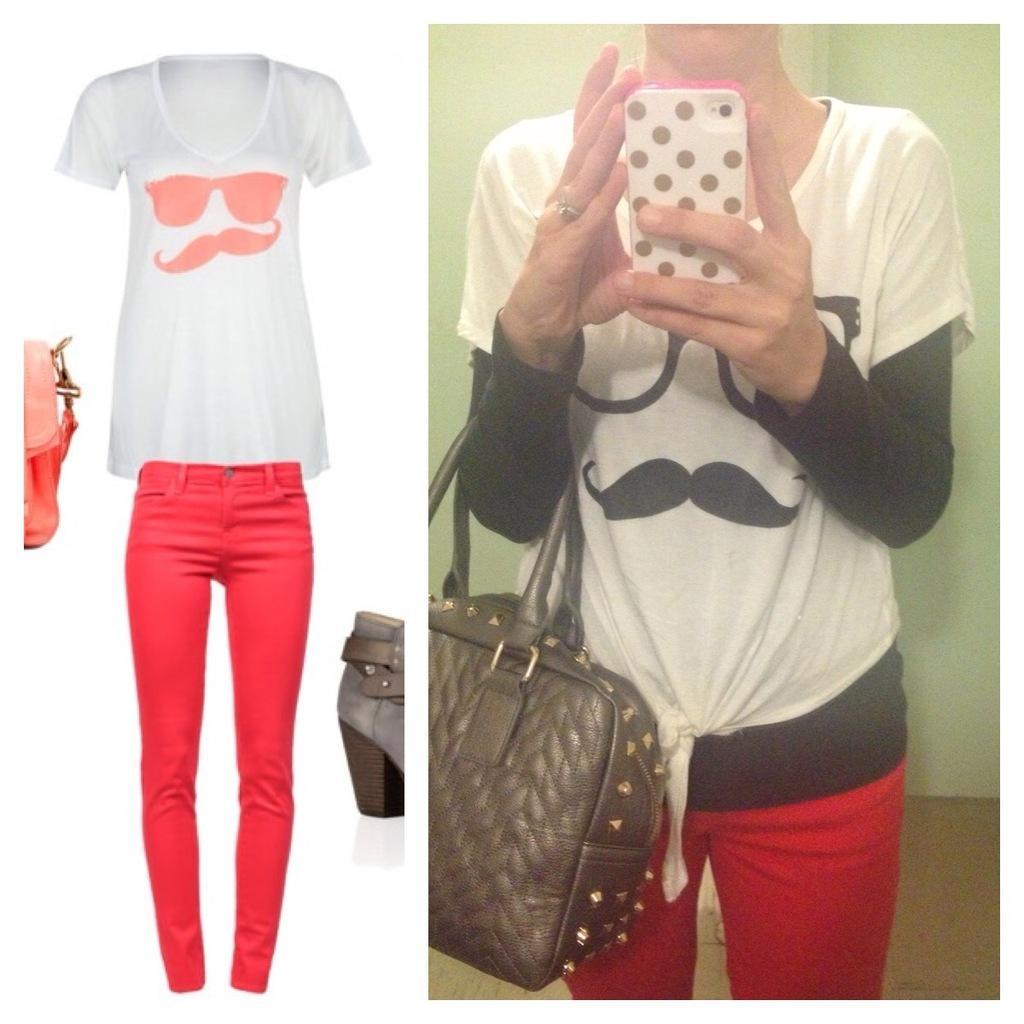Describe this image in one or two sentences. there is a person wearing a handbag and holding a mobile phone beside that there is a image of t-shirt and pant. 